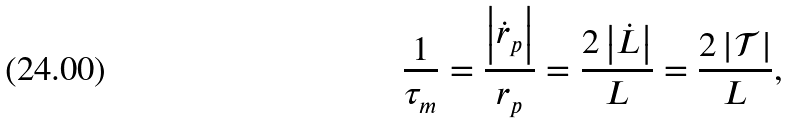Convert formula to latex. <formula><loc_0><loc_0><loc_500><loc_500>\frac { 1 } { \tau _ { m } } = \frac { \left | \dot { r } _ { p } \right | } { r _ { p } } = \frac { 2 \left | \dot { L } \right | } { L } = \frac { 2 \left | \mathcal { T } \right | } { L } ,</formula> 